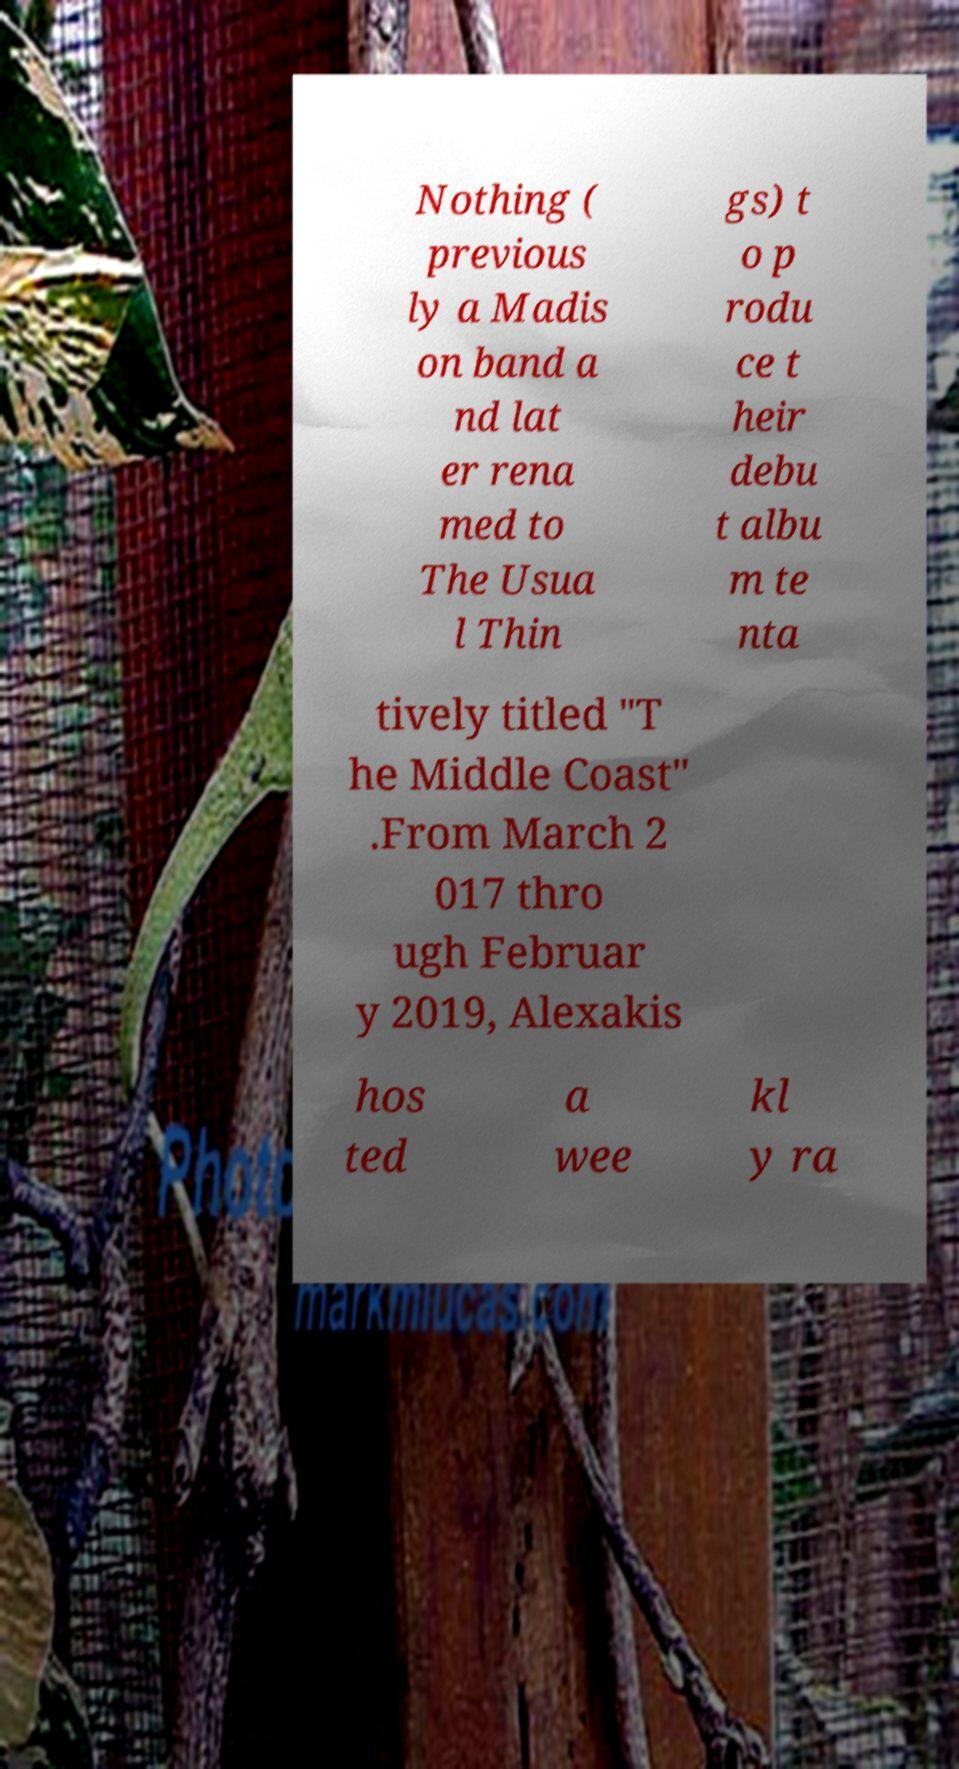Could you assist in decoding the text presented in this image and type it out clearly? Nothing ( previous ly a Madis on band a nd lat er rena med to The Usua l Thin gs) t o p rodu ce t heir debu t albu m te nta tively titled "T he Middle Coast" .From March 2 017 thro ugh Februar y 2019, Alexakis hos ted a wee kl y ra 